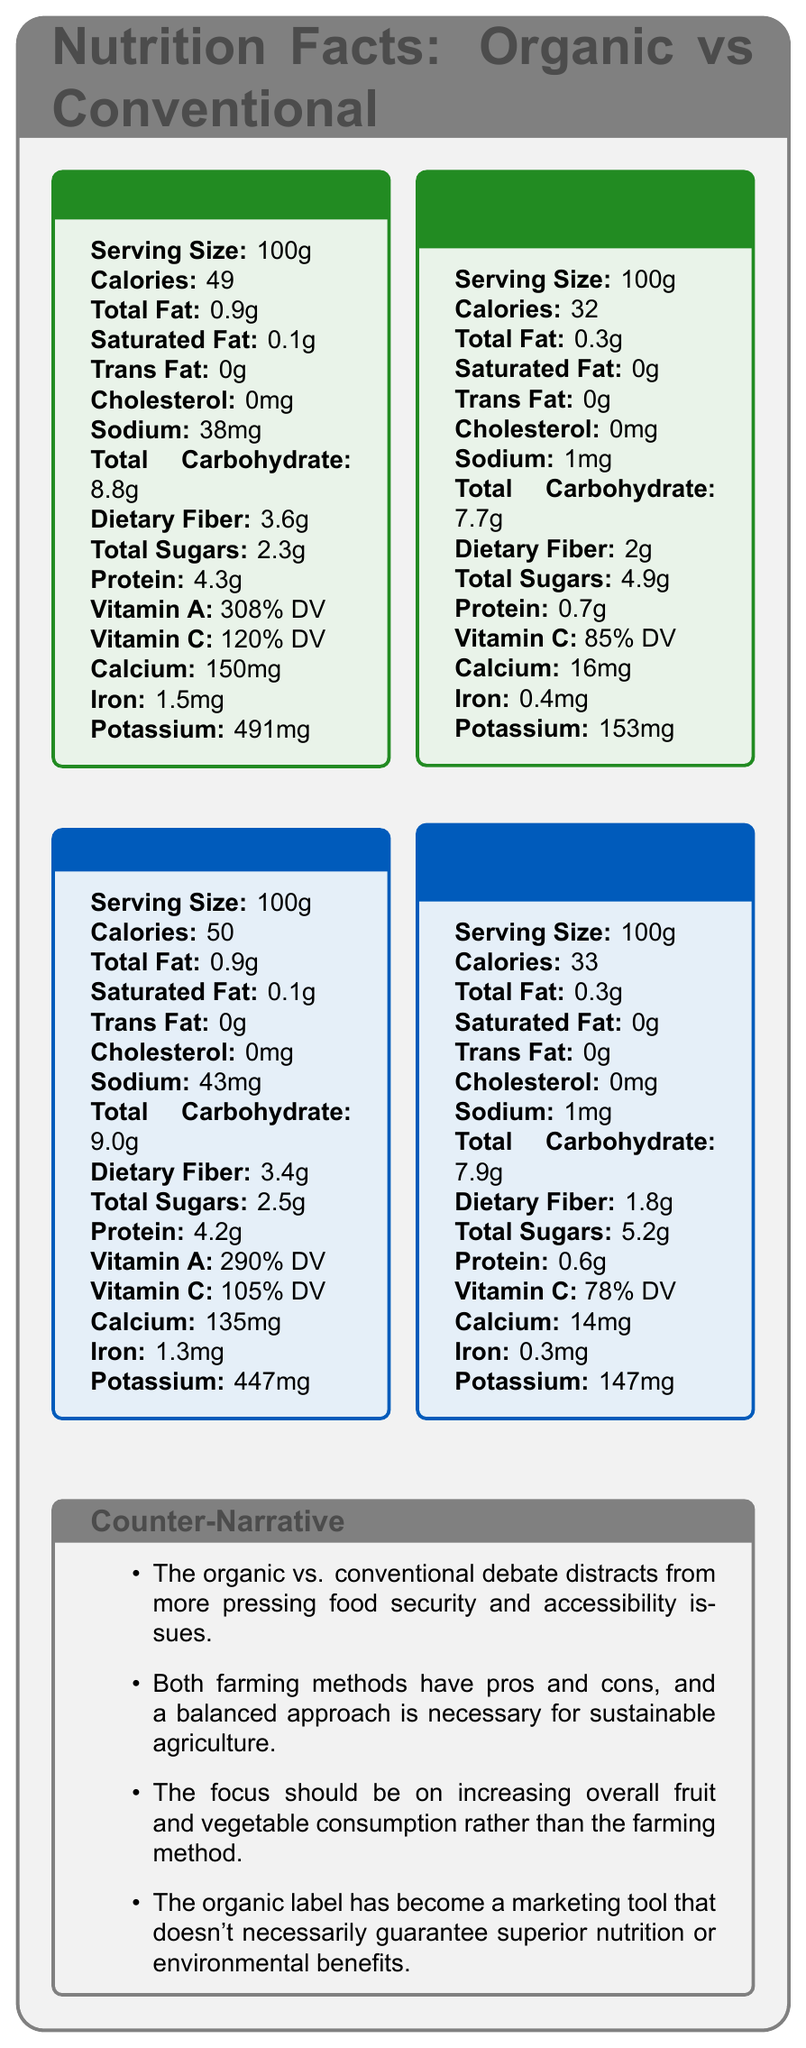what is the serving size for Organic Kale? The serving size for Organic Kale is explicitly mentioned as 100g in the document.
Answer: 100g which produce has the higher calorie count per serving, Organic Kale or Conventional Kale? According to the document, Organic Kale has 49 calories while Conventional Kale has 50 calories.
Answer: Conventional Kale How much dietary fiber is in Organic Strawberries? Organic Strawberries contain 2g of dietary fiber as listed in the document.
Answer: 2g What is the potassium content in Conventional Strawberries? The document states that Conventional Strawberries contain 147mg of potassium.
Answer: 147mg How much Vitamin C is in Organic Kale? The Vitamin C content for Organic Kale is listed as 120% Daily Value (DV) in the document.
Answer: 120% DV compare the iron content between Organic Kale and Conventional Kale? Which one has more? Organic Kale has 1.5mg of iron, whereas Conventional Kale has 1.3mg.
Answer: Organic Kale Which produce has the highest amount of total sugars? 1. Organic Kale 2. Organic Strawberries 3. Conventional Kale 4. Conventional Strawberries Conventional Strawberries have 5.2g of total sugars, which is the highest among the listed produce.
Answer: 4. Conventional Strawberries In terms of calcium content, which produce ranks highest? A. Organic Kale B. Organic Strawberries C. Conventional Kale D. Conventional Strawberries Organic Kale contains 150mg of calcium, which is higher than the calcium content in the other produce.
Answer: A. Organic Kale Is there any difference in the total fat content between Organic Kale and Conventional Kale? Both Organic Kale and Conventional Kale have the same total fat content of 0.9g.
Answer: No Has the organic label been suggested as a marketing tool rather than a guarantee of superior nutrition? The document mentions that the organic label has become a marketing tool that doesn't necessarily guarantee superior nutrition.
Answer: Yes Summarize the main focus of the document. The explanation forms a comprehensive summary of what the document entails by combining the nutrient comparison and the counter-narrative discussion.
Answer: The document compares the nutrient profiles of organic and conventional produce, specifically kale and strawberries, listing detailed nutritional information for each. It includes a counter-narrative section addressing some common arguments in the organic vs. conventional farming debate, emphasizing a balanced approach to agricultural practices and the importance of increasing overall fruit and vegetable consumption. What farming method produces higher yields? The document does not provide specific yield data for organic or conventional farming methods.
Answer: Not enough information Which argument supports the environment better according to the document, organic or conventional farming? The document states that organic farming practices are more environmentally sustainable and promote biodiversity.
Answer: Organic farming 